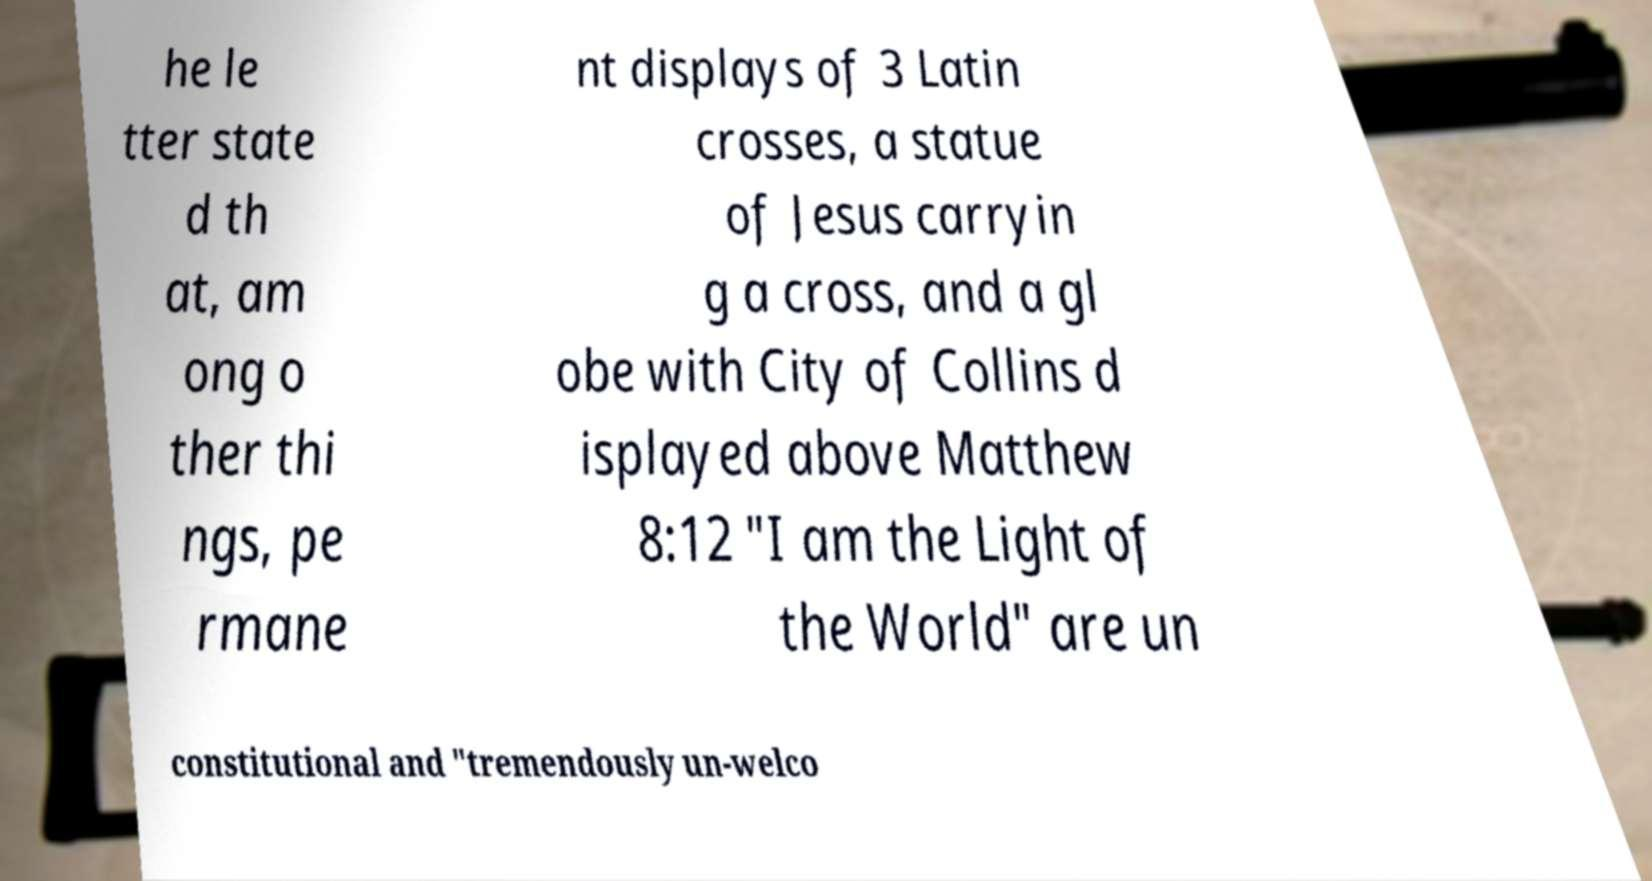For documentation purposes, I need the text within this image transcribed. Could you provide that? he le tter state d th at, am ong o ther thi ngs, pe rmane nt displays of 3 Latin crosses, a statue of Jesus carryin g a cross, and a gl obe with City of Collins d isplayed above Matthew 8:12 "I am the Light of the World" are un constitutional and "tremendously un-welco 